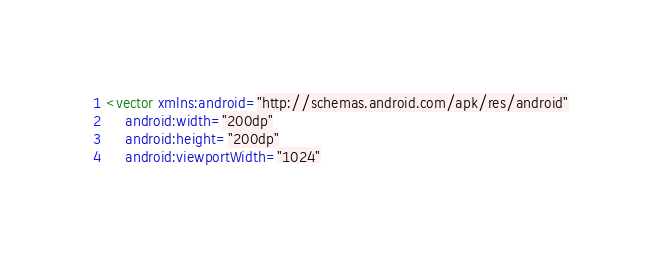<code> <loc_0><loc_0><loc_500><loc_500><_XML_><vector xmlns:android="http://schemas.android.com/apk/res/android"
    android:width="200dp"
    android:height="200dp"
    android:viewportWidth="1024"</code> 